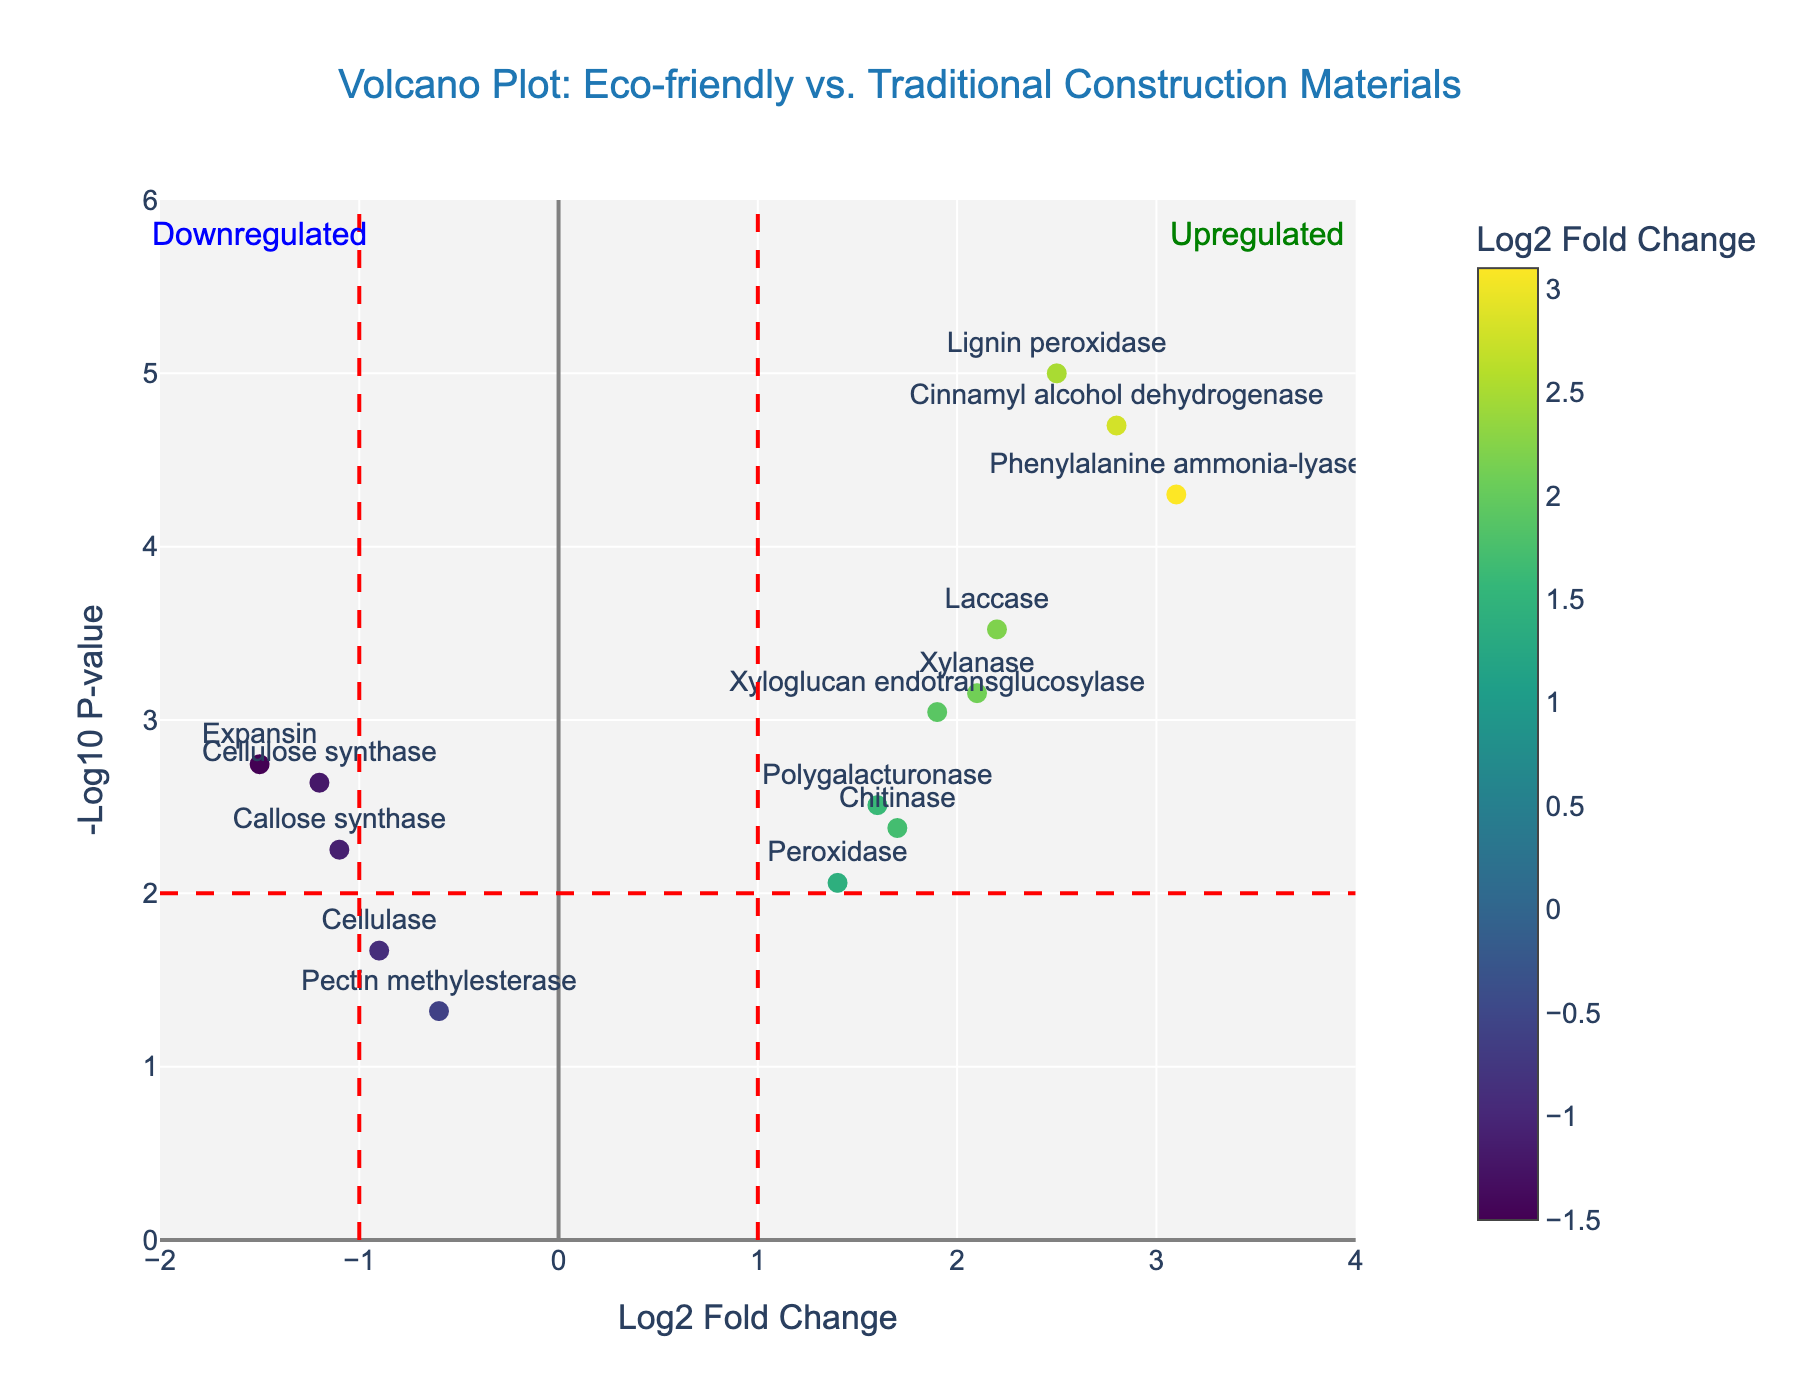How many proteins are upregulated? To identify upregulated proteins, we focus on proteins with log2 fold change > 1. From the plot, we see Lignin peroxidase, Chitinase, Phenylalanine ammonia-lyase, Laccase, Xyloglucan endotransglucosylase, Cinnamyl alcohol dehydrogenase, Peroxidase, Polygalacturonase, and Xylanase all have log2 fold change > 1.
Answer: 9 Which protein has the highest -log10(p-value)? The y-axis shows the -log10(p-value), where higher values are positioned higher on the plot. Phenylalanine ammonia-lyase has the highest -log10(p-value), since it is the highest point on the plot.
Answer: Phenylalanine ammonia-lyase What is the log2 fold change for Expansin? Expansin's position on the x-axis (log2 fold change) can be read directly from the plot. It is located at -1.5.
Answer: -1.5 Which proteins have significant differential abundance at p < 0.001? To find proteins with p < 0.001, we look for proteins above the horizontal red dashed line at y = 3 (since -log10(0.001) = 3). The proteins above this line are Lignin peroxidase, Phenylalanine ammonia-lyase, Cinnamyl alcohol dehydrogenase, and Xyloglucan endotransglucosylase.
Answer: Lignin peroxidase, Phenylalanine ammonia-lyase, Cinnamyl alcohol dehydrogenase, Xyloglucan endotransglucosylase Are there more upregulated or downregulated proteins with log2 fold change over 1? We compare the number of proteins with log2 fold change > 1 (upregulated) and < -1 (downregulated). There are 9 upregulated proteins (log2 fold change > 1) but only 3 downregulated proteins (log2 fold change < -1).
Answer: Upregulated What can be inferred about proteins with a log2 fold change close to zero? Proteins with log2 fold change close to zero (center of the x-axis) indicate no substantial change between eco-friendly and traditional materials. The central vertical area contains most proteins with changes close to zero, suggesting either no significant difference or statistical noise.
Answer: No substantial change Which protein would you consider most statistically significant? The most statistically significant protein has the smallest p-value, hence the highest -log10(p-value). From the plot, this is Phenylalanine ammonia-lyase, which has the highest vertical position.
Answer: Phenylalanine ammonia-lyase Between Lignin peroxidase and Callose synthase, which has a higher fold change? Comparing their positions on the x-axis, Lignin peroxidase has a log2 fold change of 2.5 while Callose synthase has -1.1. Therefore, Lignin peroxidase has the higher fold change.
Answer: Lignin peroxidase How many proteins have a p-value greater than 0.05? Proteins with p-value > 0.05 are below the horizontal threshold line at y = 1.301 (-log10(0.05) = 1.301). From the plot, only Pectin methylesterase falls below this line.
Answer: 1 